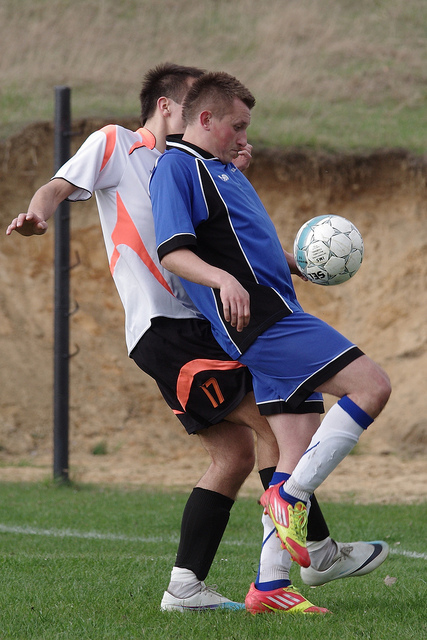<image>Why are the men wearing helmets? The men are not wearing helmets in the image. Why are the men wearing helmets? I don't know why the men are wearing helmets. But it can be for sports activities. 